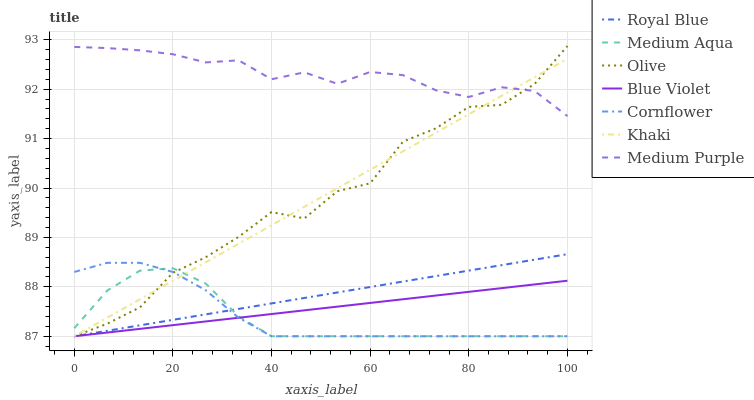Does Medium Aqua have the minimum area under the curve?
Answer yes or no. Yes. Does Medium Purple have the maximum area under the curve?
Answer yes or no. Yes. Does Khaki have the minimum area under the curve?
Answer yes or no. No. Does Khaki have the maximum area under the curve?
Answer yes or no. No. Is Blue Violet the smoothest?
Answer yes or no. Yes. Is Olive the roughest?
Answer yes or no. Yes. Is Khaki the smoothest?
Answer yes or no. No. Is Khaki the roughest?
Answer yes or no. No. Does Cornflower have the lowest value?
Answer yes or no. Yes. Does Medium Purple have the lowest value?
Answer yes or no. No. Does Olive have the highest value?
Answer yes or no. Yes. Does Khaki have the highest value?
Answer yes or no. No. Is Cornflower less than Medium Purple?
Answer yes or no. Yes. Is Medium Purple greater than Blue Violet?
Answer yes or no. Yes. Does Royal Blue intersect Medium Aqua?
Answer yes or no. Yes. Is Royal Blue less than Medium Aqua?
Answer yes or no. No. Is Royal Blue greater than Medium Aqua?
Answer yes or no. No. Does Cornflower intersect Medium Purple?
Answer yes or no. No. 